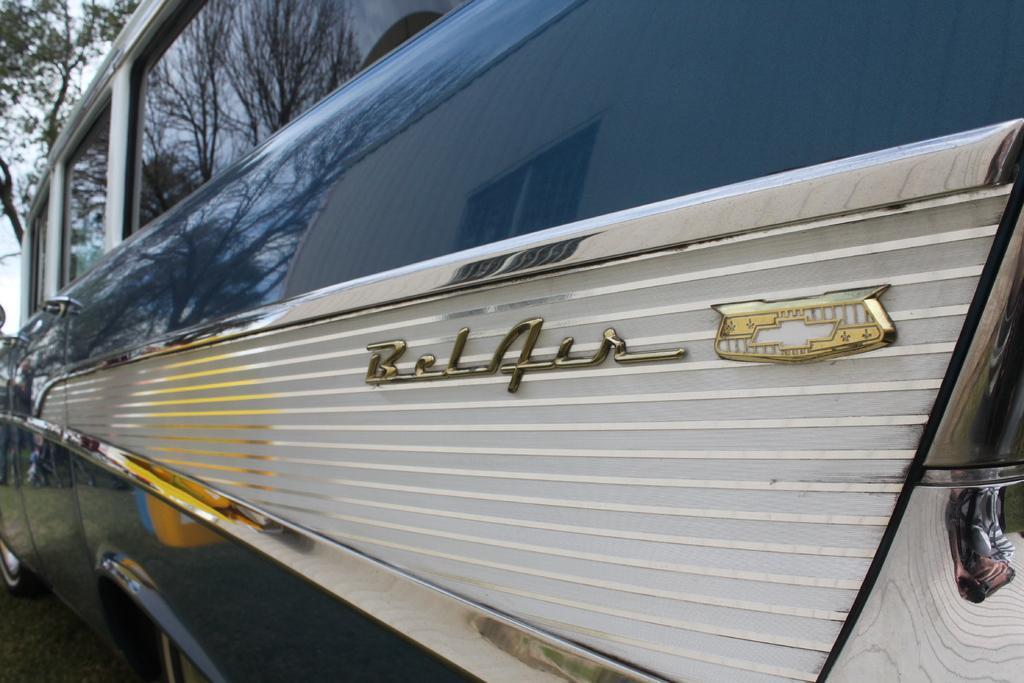How would you summarize this image in a sentence or two? In this image there is a vehicle. We can see the wordings on the vehicle. There is a road. There are trees in the background. There is a sky. 